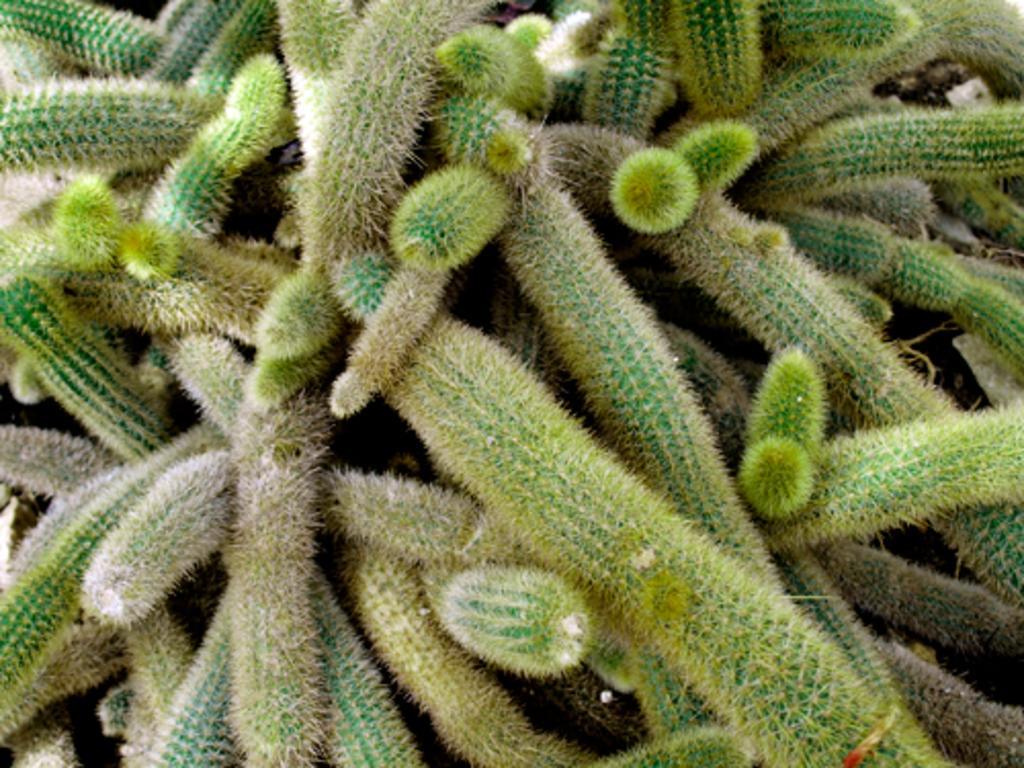Could you give a brief overview of what you see in this image? This is the picture of a plant. 